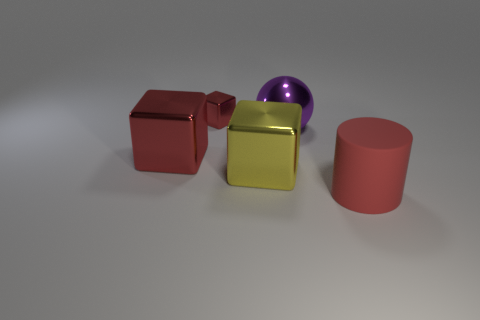Are the large red thing to the left of the red cylinder and the red thing that is to the right of the large yellow cube made of the same material?
Give a very brief answer. No. There is a red metal object that is the same size as the cylinder; what shape is it?
Your answer should be compact. Cube. Is there another thing of the same shape as the big red metal object?
Give a very brief answer. Yes. There is a big thing that is to the left of the yellow block; is it the same color as the cube that is to the right of the tiny red shiny cube?
Provide a short and direct response. No. There is a big red metallic block; are there any tiny cubes on the left side of it?
Provide a short and direct response. No. There is a thing that is to the left of the rubber cylinder and right of the yellow metal object; what is it made of?
Give a very brief answer. Metal. Is the material of the big red thing that is on the left side of the big cylinder the same as the small object?
Your answer should be compact. Yes. What material is the small red block?
Ensure brevity in your answer.  Metal. There is a red cube on the left side of the small cube; what is its size?
Give a very brief answer. Large. Is there any other thing that is the same color as the large shiny ball?
Give a very brief answer. No. 